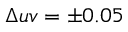Convert formula to latex. <formula><loc_0><loc_0><loc_500><loc_500>\Delta u v = \pm 0 . 0 5</formula> 